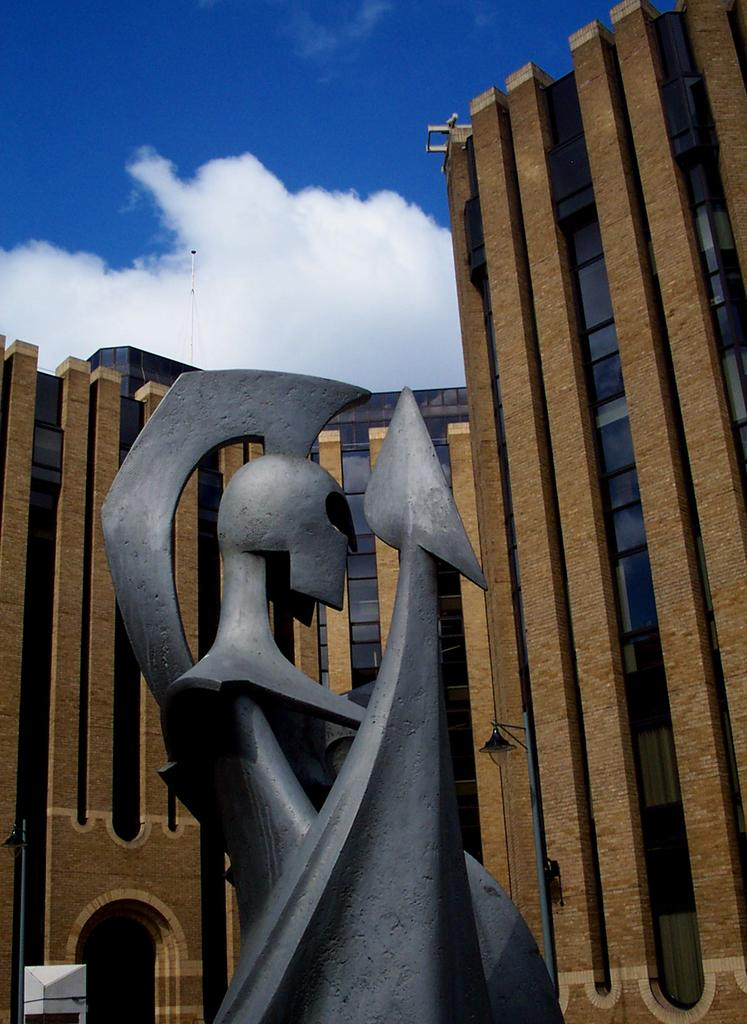What is the main subject of the image? There is a sculpture in the image. What can be seen in the background of the image? There are buildings visible in the background of the image. What is visible above the sculpture and buildings? The sky is visible in the image. What is the condition of the sky in the image? Clouds are present in the sky. What type of rat can be seen participating in the battle in the image? There is no battle or rat present in the image; it features a sculpture with a background of buildings and a sky with clouds. 